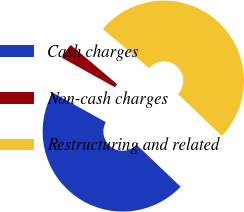Convert chart to OTSL. <chart><loc_0><loc_0><loc_500><loc_500><pie_chart><fcel>Cash charges<fcel>Non-cash charges<fcel>Restructuring and related<nl><fcel>45.96%<fcel>3.11%<fcel>50.93%<nl></chart> 